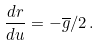<formula> <loc_0><loc_0><loc_500><loc_500>\frac { d r } { d u } = - { \overline { g } } / 2 \, .</formula> 